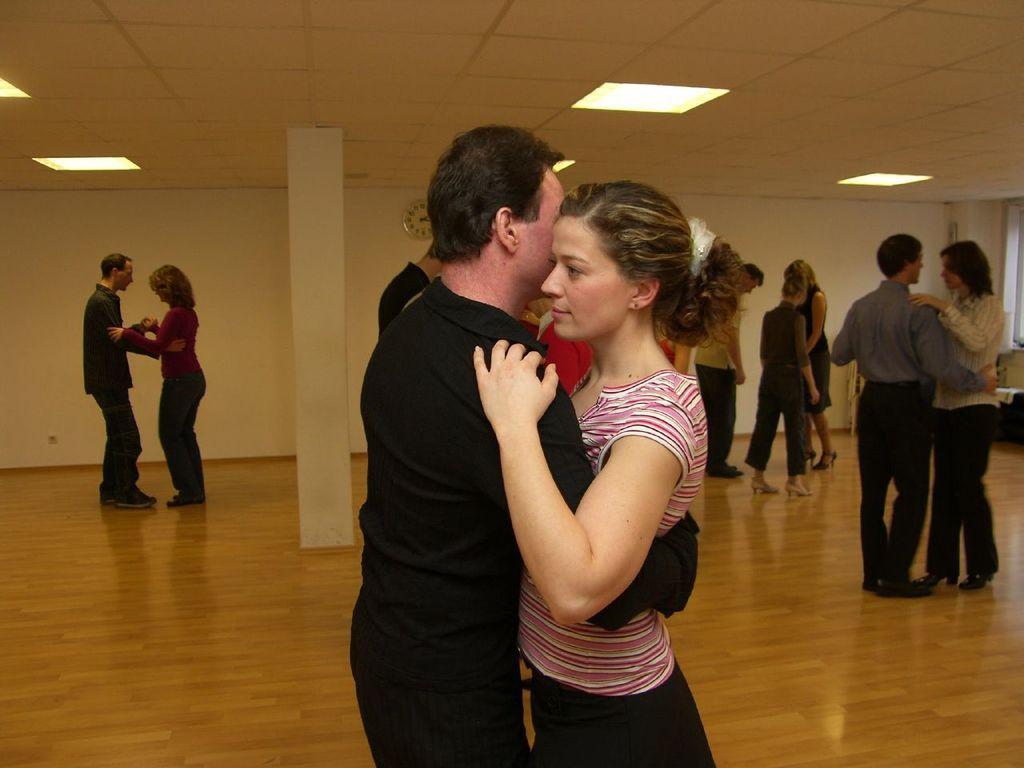Who are the two people in the center of the image? There is a couple standing in the center of the image. What is the couple standing on? The couple is standing on the floor. What can be seen in the background of the image? There are many persons, a pillar, a wall, and lights in the background of the image. What type of whip is being used by the couple in the image? There is no whip present in the image; the couple is simply standing together. What position are the couple's hands in the image? The provided facts do not specify the position of the couple's hands, so it cannot be determined from the image. 